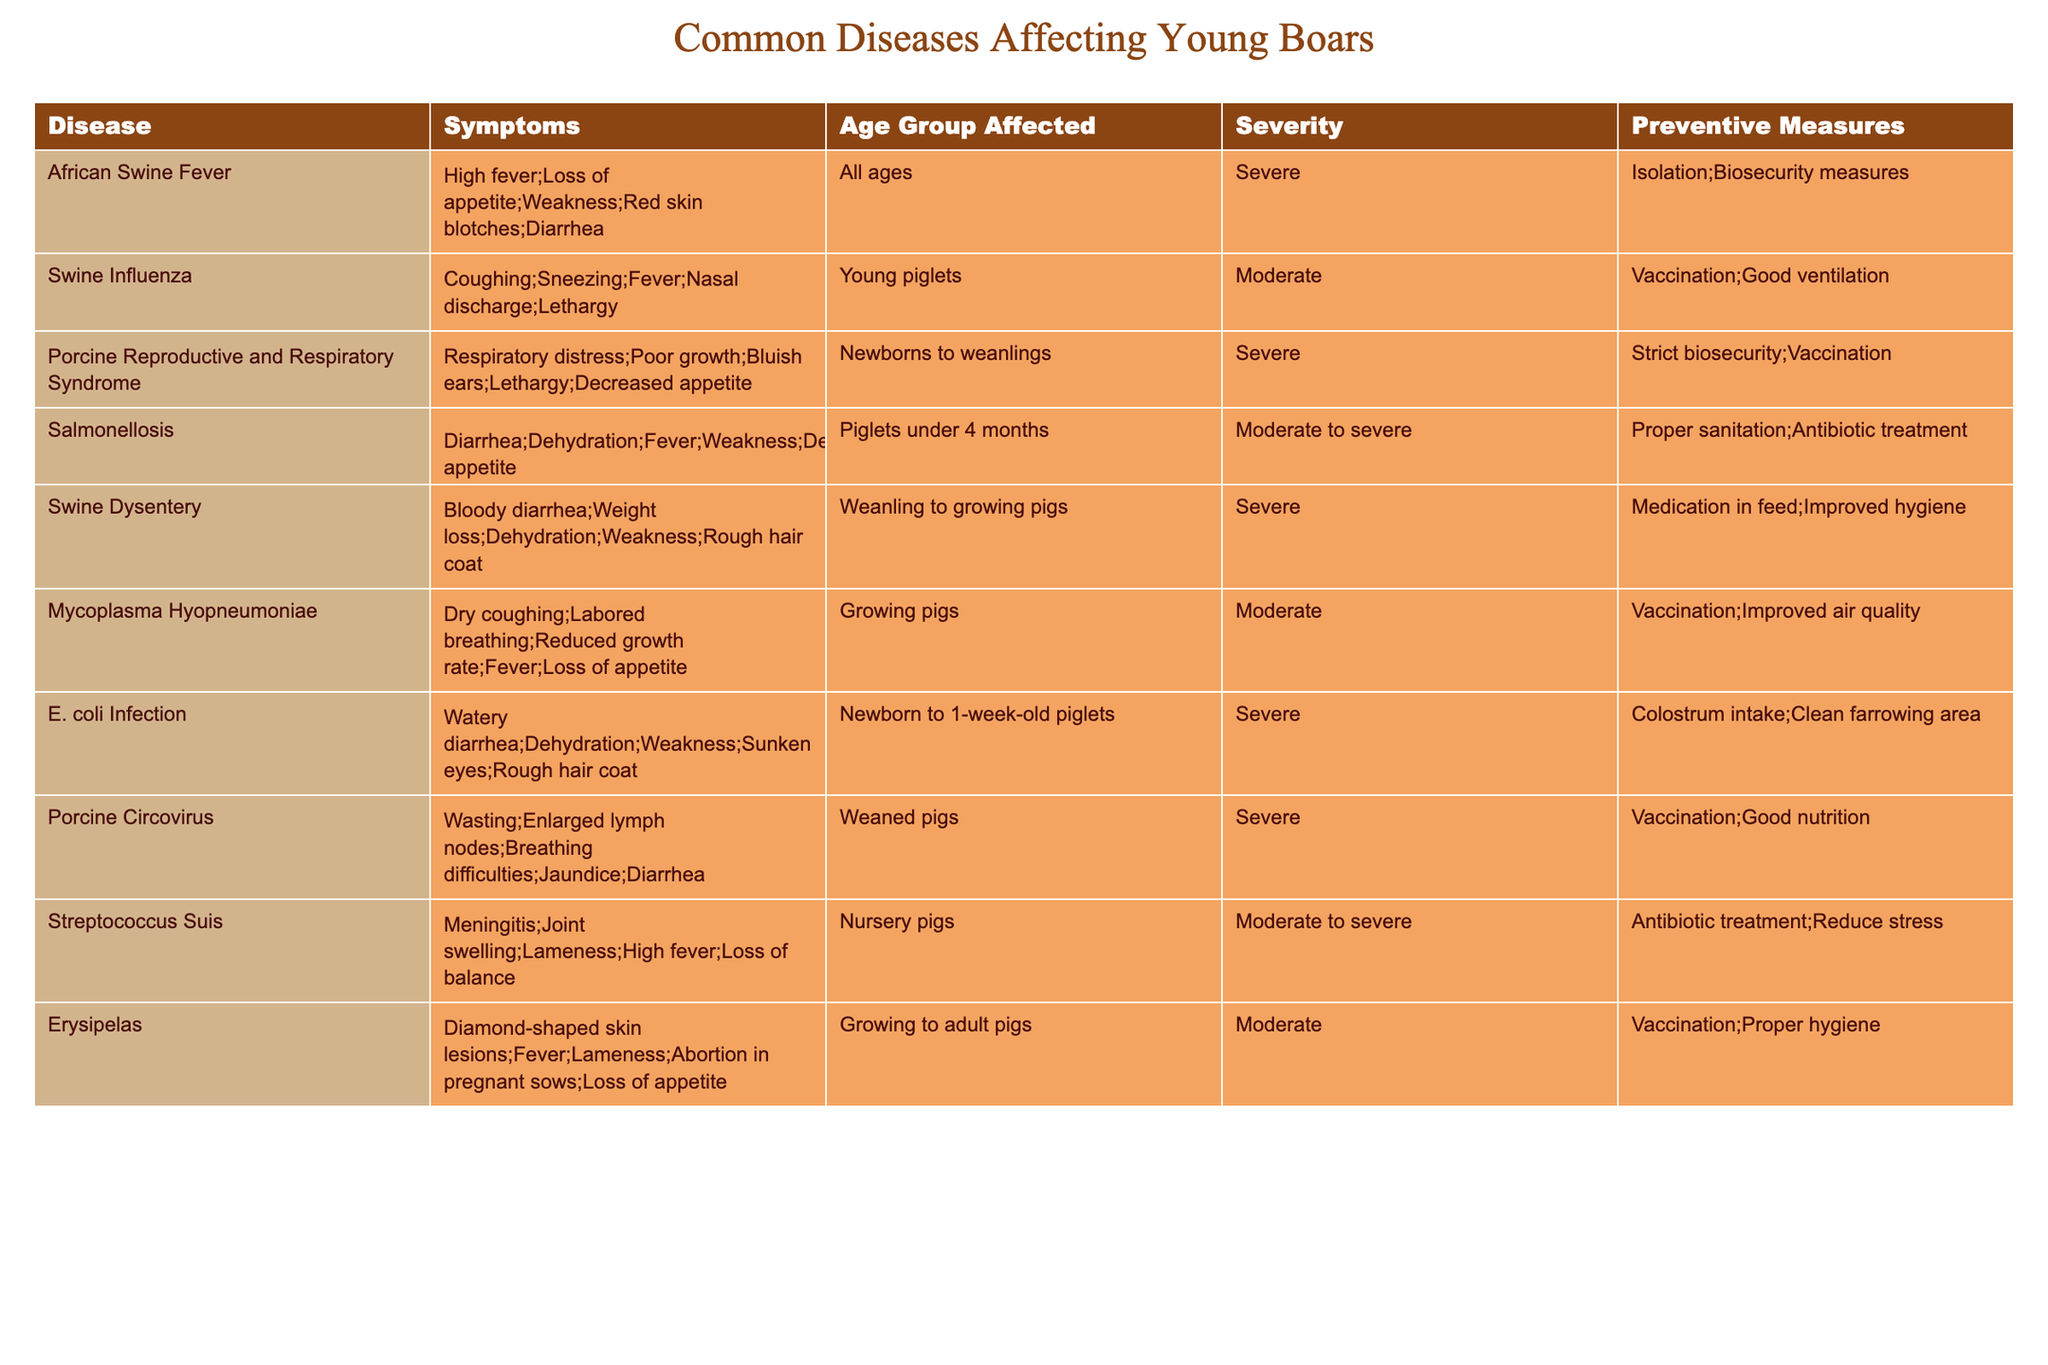What are the symptoms of African Swine Fever? The table lists the symptoms of African Swine Fever as high fever, loss of appetite, weakness, red skin blotches, and diarrhea.
Answer: High fever, loss of appetite, weakness, red skin blotches, diarrhea Which disease affects piglets under 4 months old? According to the table, Salmonellosis is the disease that specifically affects piglets under 4 months old.
Answer: Salmonellosis Is Porcine Reproductive and Respiratory Syndrome severe in young boars? Yes, the table indicates that Porcine Reproductive and Respiratory Syndrome is classified as severe.
Answer: Yes How many diseases listed affect newborns? The table shows that E. coli Infection and Porcine Reproductive and Respiratory Syndrome affect newborns. Therefore, there are 2 diseases.
Answer: 2 What symptoms are common in diseases affecting weanling to growing pigs? The symptoms listed for diseases affecting weanling to growing pigs include bloody diarrhea, weight loss, dehydration, weakness, and rough hair coat for Swine Dysentery, and dry coughing, labored breathing, reduced growth rate, fever, and loss of appetite for Mycoplasma Hyopneumoniae.
Answer: Bloody diarrhea, weight loss, dehydration, weakness, rough hair coat, dry coughing, labored breathing, reduced growth rate, fever, loss of appetite Which disease has the highest severity rating, and what are its preventive measures? African Swine Fever is labeled with the highest severity rating of severe, and its preventive measures include isolation and biosecurity measures.
Answer: African Swine Fever; isolation, biosecurity measures Are there any diseases listed that require antibiotic treatment? Yes, Salmonellosis and Streptococcus Suis are listed in the table as requiring antibiotic treatment.
Answer: Yes What is the most common symptom among the diseases affecting growing pigs? The most common symptom among the listed diseases affecting growing pigs appears to be weakness, as it is mentioned in both Salmonellosis and other diseases.
Answer: Weakness How many diseases have vaccination listed as a preventive measure? The diseases that have vaccination listed as a preventive measure are Swine Influenza, Porcine Reproductive and Respiratory Syndrome, Mycoplasma Hyopneumoniae, Porcine Circovirus, and Erysipelas. This totals 5 diseases.
Answer: 5 What age group is affected by E. coli Infection? The table states that E. coli Infection affects newborn to 1-week-old piglets.
Answer: Newborn to 1-week-old piglets If a young boar shows lethargy, which diseases could it possibly have? The diseases listed with lethargy as a symptom include Swine Influenza, Porcine Reproductive and Respiratory Syndrome, Salmonellosis, Mycoplasma Hyopneumoniae, and Streptococcus Suis. Therefore, it could possibly have any of these diseases.
Answer: 5 diseases: Swine Influenza, Porcine Reproductive and Respiratory Syndrome, Salmonellosis, Mycoplasma Hyopneumoniae, Streptococcus Suis 